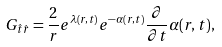Convert formula to latex. <formula><loc_0><loc_0><loc_500><loc_500>G _ { \hat { t } \hat { r } } = \frac { 2 } { r } e ^ { \lambda ( r , t ) } e ^ { - \alpha ( r , t ) } \frac { \partial } { \partial t } \alpha ( r , t ) ,</formula> 